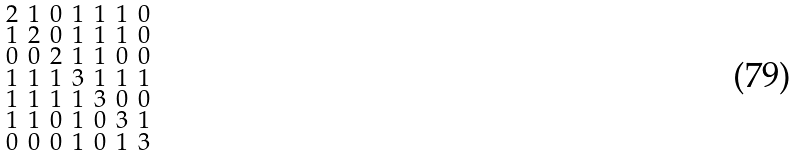<formula> <loc_0><loc_0><loc_500><loc_500>\begin{smallmatrix} 2 & 1 & 0 & 1 & 1 & 1 & 0 \\ 1 & 2 & 0 & 1 & 1 & 1 & 0 \\ 0 & 0 & 2 & 1 & 1 & 0 & 0 \\ 1 & 1 & 1 & 3 & 1 & 1 & 1 \\ 1 & 1 & 1 & 1 & 3 & 0 & 0 \\ 1 & 1 & 0 & 1 & 0 & 3 & 1 \\ 0 & 0 & 0 & 1 & 0 & 1 & 3 \end{smallmatrix}</formula> 